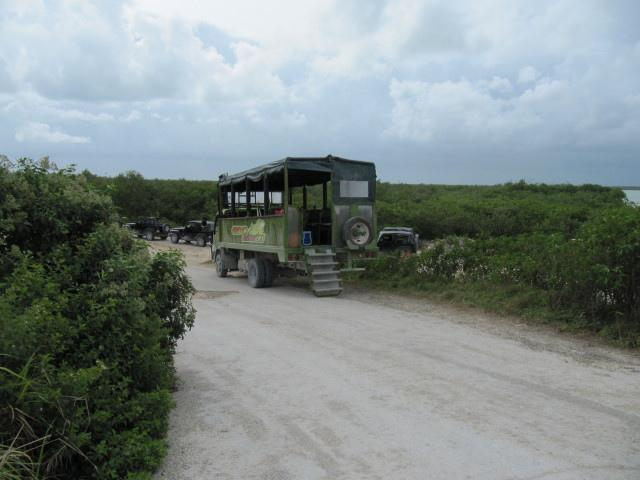What does the truck have a spare of on the back?

Choices:
A) gas tank
B) tire
C) motor
D) seat tire 